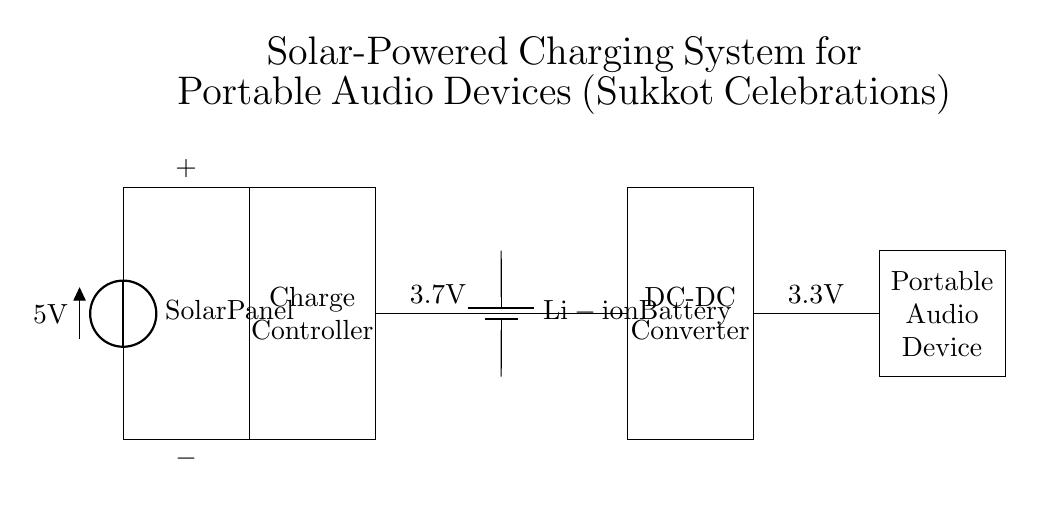What is the first component in the circuit? The first component in the circuit is the Solar Panel, which is depicted at the top left of the diagram.
Answer: Solar Panel What is the voltage output of the Solar Panel? The Solar Panel has an output voltage of 5 volts, as indicated on the diagram next to the component.
Answer: 5 volts What type of battery is used in this circuit? The circuit uses a lithium-ion battery, which is shown in the central part of the diagram labeled accordingly.
Answer: Li-ion Battery How many components are used in the charging circuit? There are five components in total within the circuit: the Solar Panel, Charge Controller, Battery, DC-DC Converter, and Portable Audio Device.
Answer: Five components What is the output voltage of the Portable Audio Device? The output voltage of the Portable Audio Device is 3.3 volts, as noted in the diagram near the component.
Answer: 3.3 volts What is the role of the Charge Controller in this circuit? The Charge Controller regulates the voltage from the Solar Panel to ensure that the battery is charged safely and efficiently. This is implied through its positioning between the panel and the battery.
Answer: Regulates charging Why is a DC-DC Converter used in this charging system? The DC-DC Converter is necessary to step down the voltage from the battery to a level suitable for the Portable Audio Device, ensuring proper functionality. This is inferred from the directional flow of the circuit and voltage specifications.
Answer: Steps down voltage 